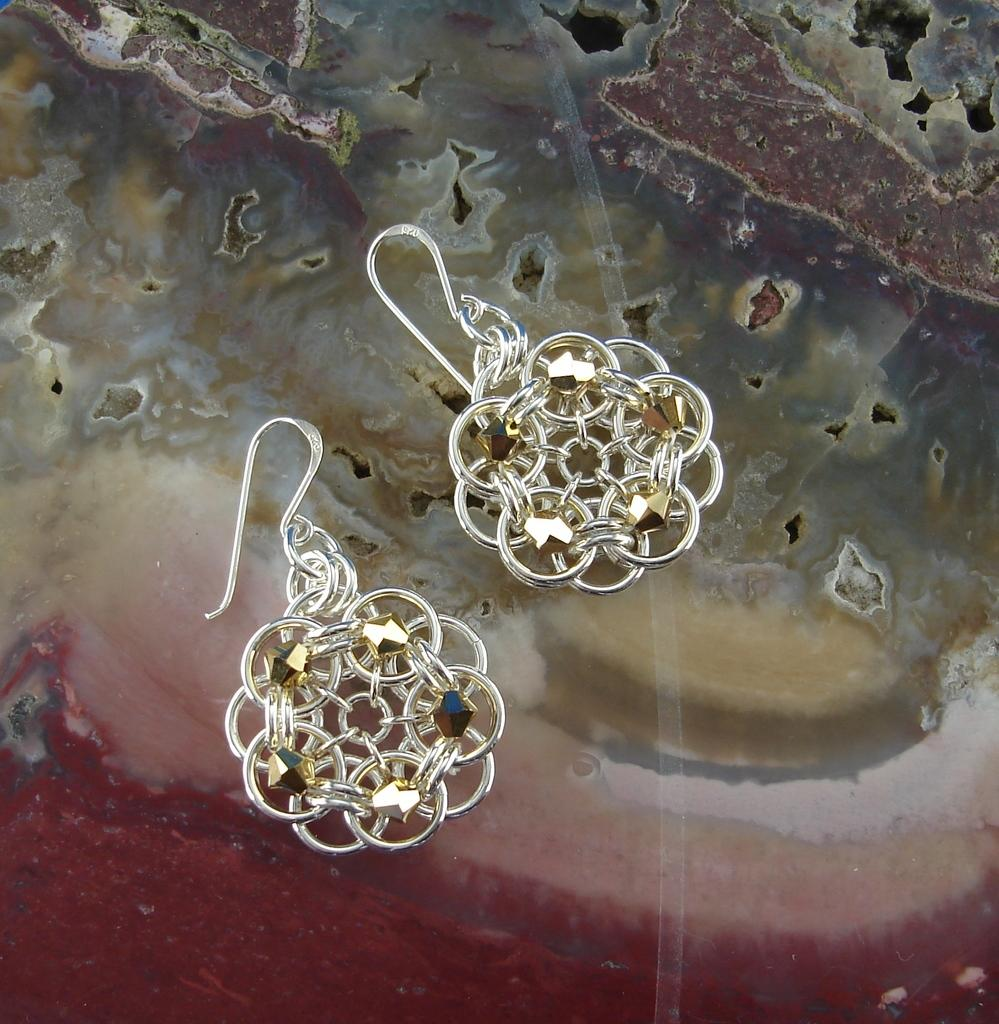What type of event or gathering might be depicted in the image? Based on the assumption that the image contains a family gathering or event, it might depict a family gathering or event. Can you describe any specific elements or objects that might be present in a family gathering or event? In a family gathering or event, there might be elements such as family members, food, and possibly a frame or photo displaying family memories. How might the family members be interacting with each other in the image? The family members might be interacting with each other through conversation, laughter, or other forms of social engagement. What type of trade negotiations can be seen taking place in the image? There is no indication in the image that trade negotiations are taking place. What type of frame is visible in the image? Based on the assumption that the image contains a family gathering or event, there might be a frame or photo displaying family memories. However, the specific type of frame cannot be determined from the image alone. 